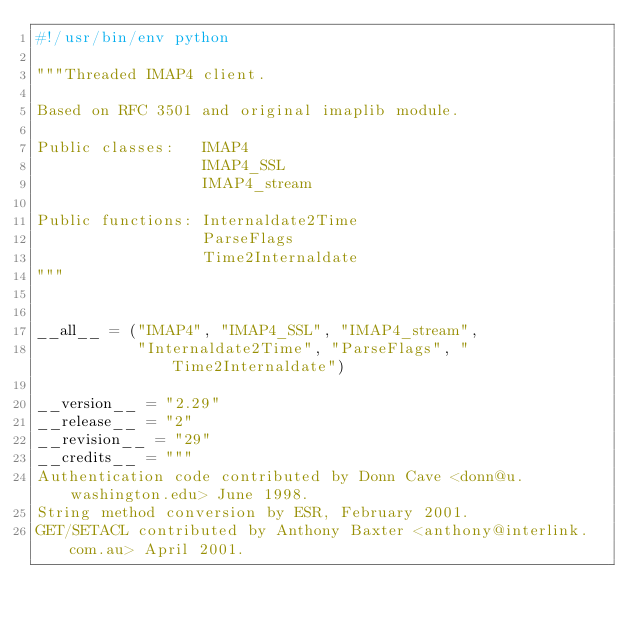<code> <loc_0><loc_0><loc_500><loc_500><_Python_>#!/usr/bin/env python

"""Threaded IMAP4 client.

Based on RFC 3501 and original imaplib module.

Public classes:   IMAP4
                  IMAP4_SSL
                  IMAP4_stream

Public functions: Internaldate2Time
                  ParseFlags
                  Time2Internaldate
"""


__all__ = ("IMAP4", "IMAP4_SSL", "IMAP4_stream",
           "Internaldate2Time", "ParseFlags", "Time2Internaldate")

__version__ = "2.29"
__release__ = "2"
__revision__ = "29"
__credits__ = """
Authentication code contributed by Donn Cave <donn@u.washington.edu> June 1998.
String method conversion by ESR, February 2001.
GET/SETACL contributed by Anthony Baxter <anthony@interlink.com.au> April 2001.</code> 